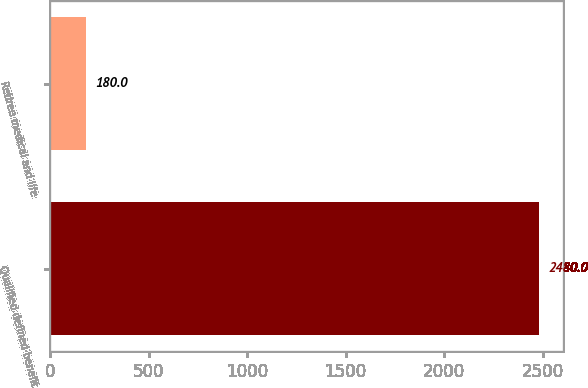<chart> <loc_0><loc_0><loc_500><loc_500><bar_chart><fcel>Qualified defined benefit<fcel>Retiree medical and life<nl><fcel>2480<fcel>180<nl></chart> 